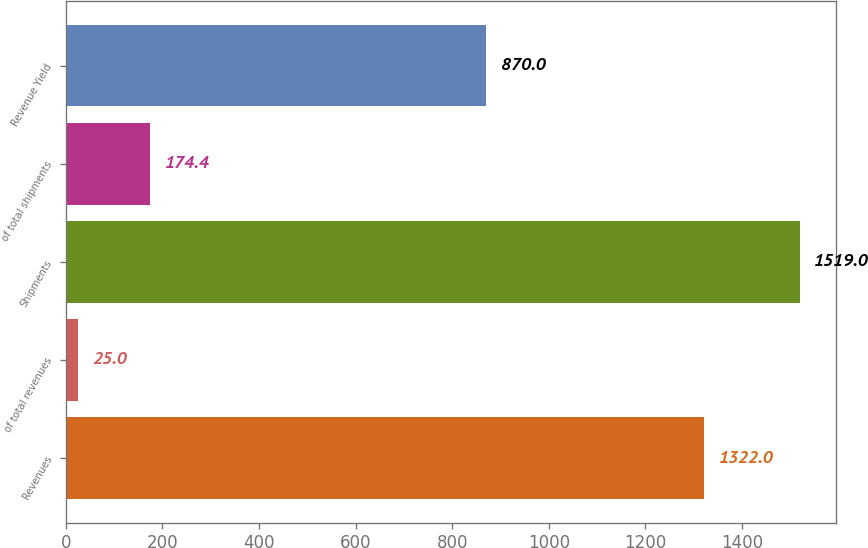Convert chart to OTSL. <chart><loc_0><loc_0><loc_500><loc_500><bar_chart><fcel>Revenues<fcel>of total revenues<fcel>Shipments<fcel>of total shipments<fcel>Revenue Yield<nl><fcel>1322<fcel>25<fcel>1519<fcel>174.4<fcel>870<nl></chart> 